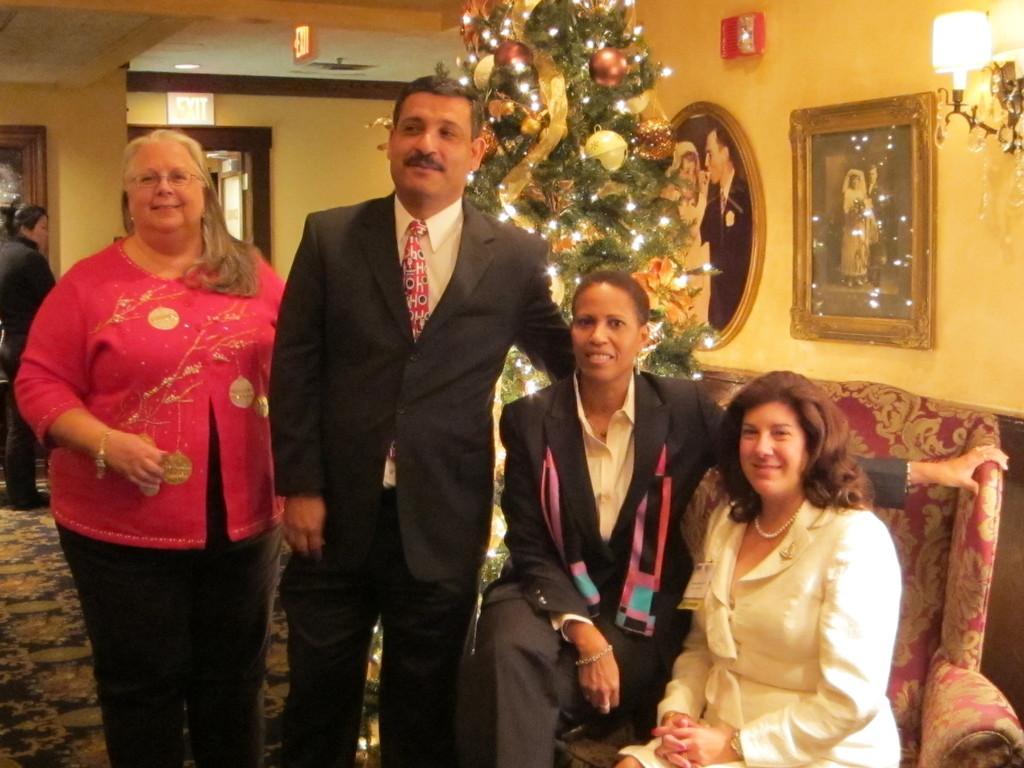Describe this image in one or two sentences. In this image we can see a group of people standing on the floor. On the right side we can see two women sitting on a sofa. We can also see the Christmas tree with lights and balls on it, some photo frames and a lamp to a wall. On the backside we can see a signboard and a roof with some ceiling lights. 